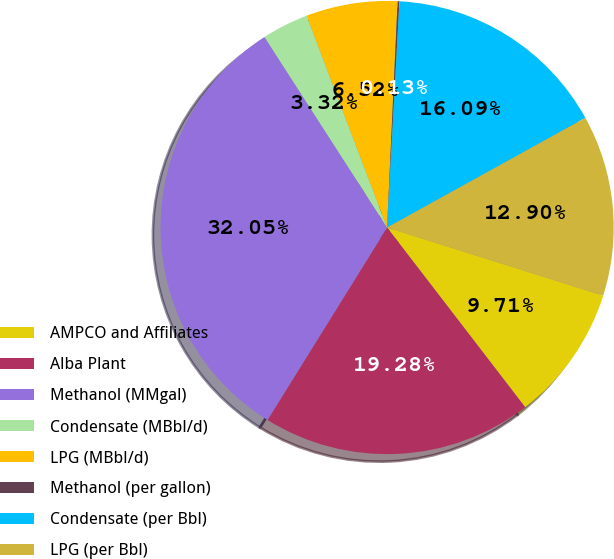Convert chart to OTSL. <chart><loc_0><loc_0><loc_500><loc_500><pie_chart><fcel>AMPCO and Affiliates<fcel>Alba Plant<fcel>Methanol (MMgal)<fcel>Condensate (MBbl/d)<fcel>LPG (MBbl/d)<fcel>Methanol (per gallon)<fcel>Condensate (per Bbl)<fcel>LPG (per Bbl)<nl><fcel>9.71%<fcel>19.28%<fcel>32.05%<fcel>3.32%<fcel>6.52%<fcel>0.13%<fcel>16.09%<fcel>12.9%<nl></chart> 